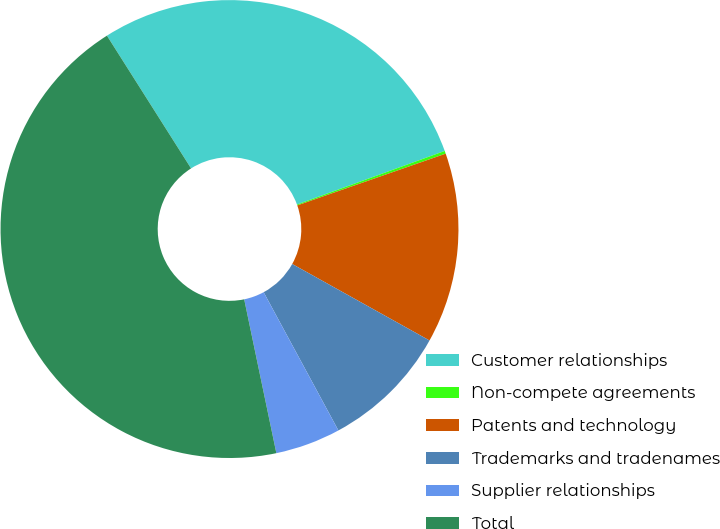<chart> <loc_0><loc_0><loc_500><loc_500><pie_chart><fcel>Customer relationships<fcel>Non-compete agreements<fcel>Patents and technology<fcel>Trademarks and tradenames<fcel>Supplier relationships<fcel>Total<nl><fcel>28.45%<fcel>0.2%<fcel>13.43%<fcel>9.02%<fcel>4.61%<fcel>44.29%<nl></chart> 